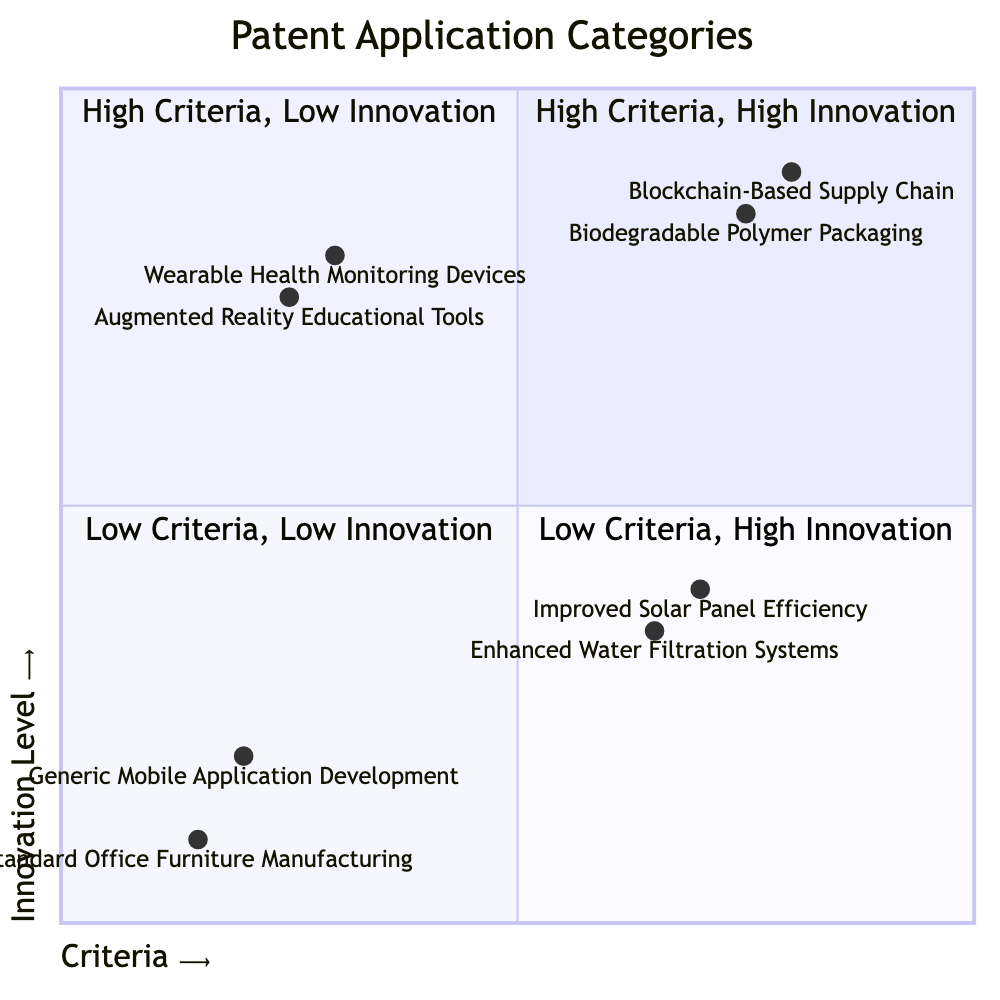What are the titles of the examples in the quadrant "High Criteria, High Innovation"? The quadrant "High Criteria, High Innovation" includes the examples "Blockchain-Based Supply Chain Monitoring" and "Biodegradable Polymer Packaging."
Answer: Blockchain-Based Supply Chain Monitoring, Biodegradable Polymer Packaging How many examples are listed in the "Low Criteria, Low Innovation" quadrant? The "Low Criteria, Low Innovation" quadrant contains two examples: "Generic Mobile Application Development" and "Standard Office Furniture Manufacturing."
Answer: 2 Which example has the highest innovation level? The example "Blockchain-Based Supply Chain Monitoring" is located at coordinates [0.8, 0.9], which is the highest y-coordinate among all examples, indicating it has the highest innovation level.
Answer: Blockchain-Based Supply Chain Monitoring What is the innovation level of "Improved Solar Panel Efficiency"? "Improved Solar Panel Efficiency" is located at coordinates [0.7, 0.4], which indicates an innovation level of 0.4.
Answer: 0.4 Which quadrant contains "Wearable Health Monitoring Devices"? "Wearable Health Monitoring Devices" is located in the "Low Criteria, High Innovation" quadrant based on its coordinates [0.3, 0.8].
Answer: Low Criteria, High Innovation What is the criteria value for "Biodegradable Polymer Packaging"? "Biodegradable Polymer Packaging" has a criteria value of 0.75, as indicated by its coordinates [0.75, 0.85].
Answer: 0.75 Which quadrant has only examples with low innovation levels? The "Low Criteria, Low Innovation" quadrant is the only one that includes examples that have low innovation levels, as shown by the coordinates of its examples.
Answer: Low Criteria, Low Innovation What are the coordinates for "Augmented Reality Educational Tools"? "Augmented Reality Educational Tools" is found at coordinates [0.25, 0.75], which denote its position in the quadrant chart.
Answer: [0.25, 0.75] 